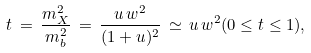Convert formula to latex. <formula><loc_0><loc_0><loc_500><loc_500>t \, = \, \frac { m _ { X } ^ { 2 } } { m _ { b } ^ { 2 } } \, = \, \frac { u \, w ^ { 2 } } { ( 1 + u ) ^ { 2 } } \, \simeq \, u \, w ^ { 2 } ( 0 \leq t \leq 1 ) ,</formula> 